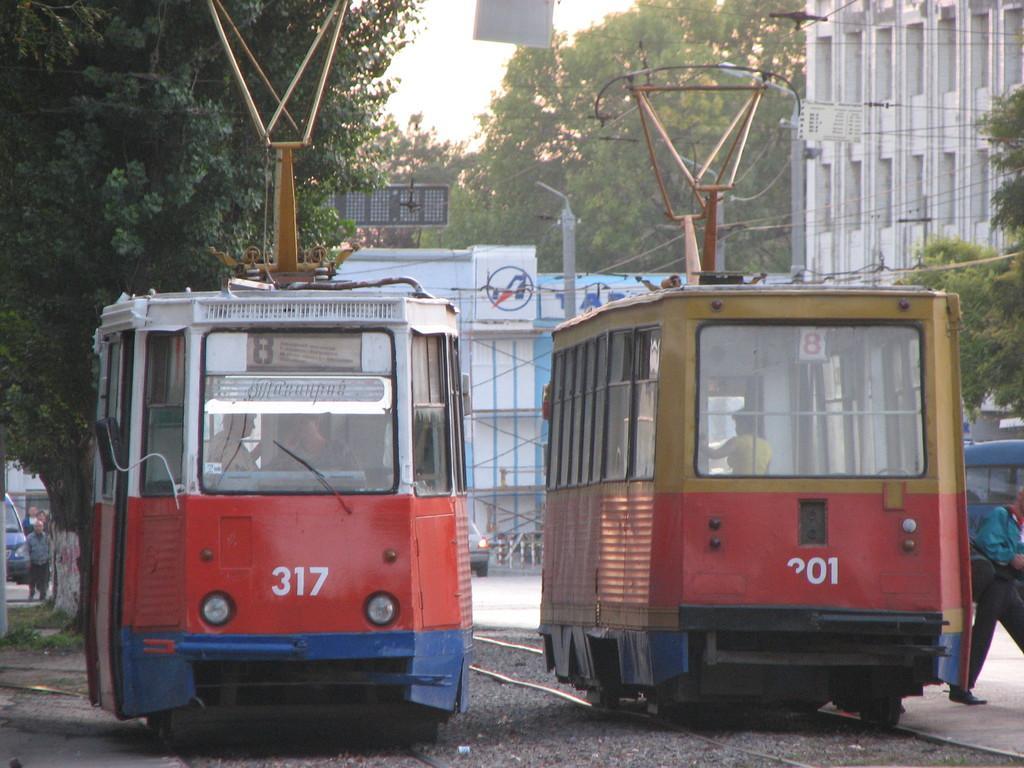Could you give a brief overview of what you see in this image? In this picture we can observe two rail engines moving on the railway tracks which were in red and blue color. We can observe wires. There are buildings in this picture. We can observe trees. In the background there is a sky. 